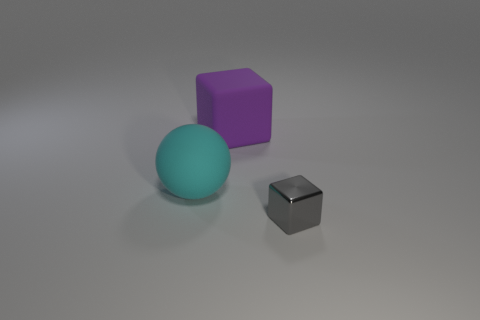Add 1 small yellow cylinders. How many objects exist? 4 Subtract all spheres. How many objects are left? 2 Subtract all tiny things. Subtract all tiny matte cylinders. How many objects are left? 2 Add 1 tiny gray shiny cubes. How many tiny gray shiny cubes are left? 2 Add 3 green metal balls. How many green metal balls exist? 3 Subtract 0 brown cylinders. How many objects are left? 3 